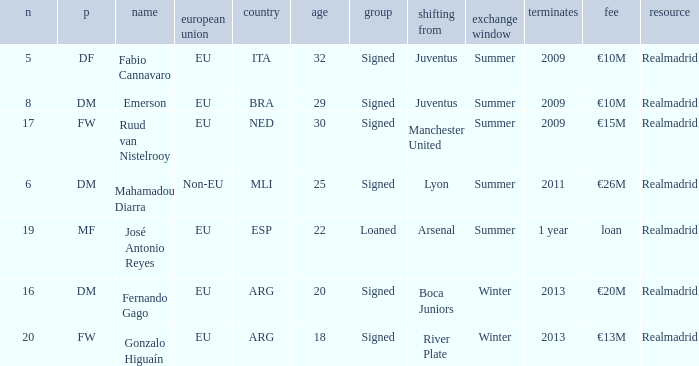What is the EU status of ESP? EU. 